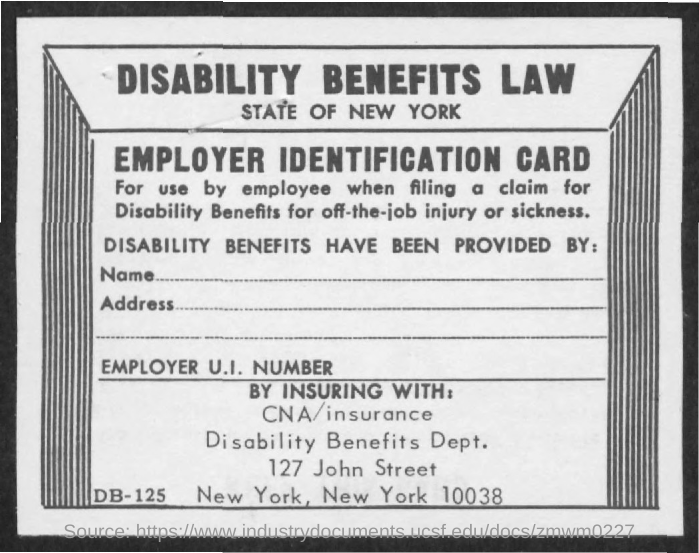Outline some significant characteristics in this image. The title of the page is 'DISABILITY BENEFITS LAW.' 